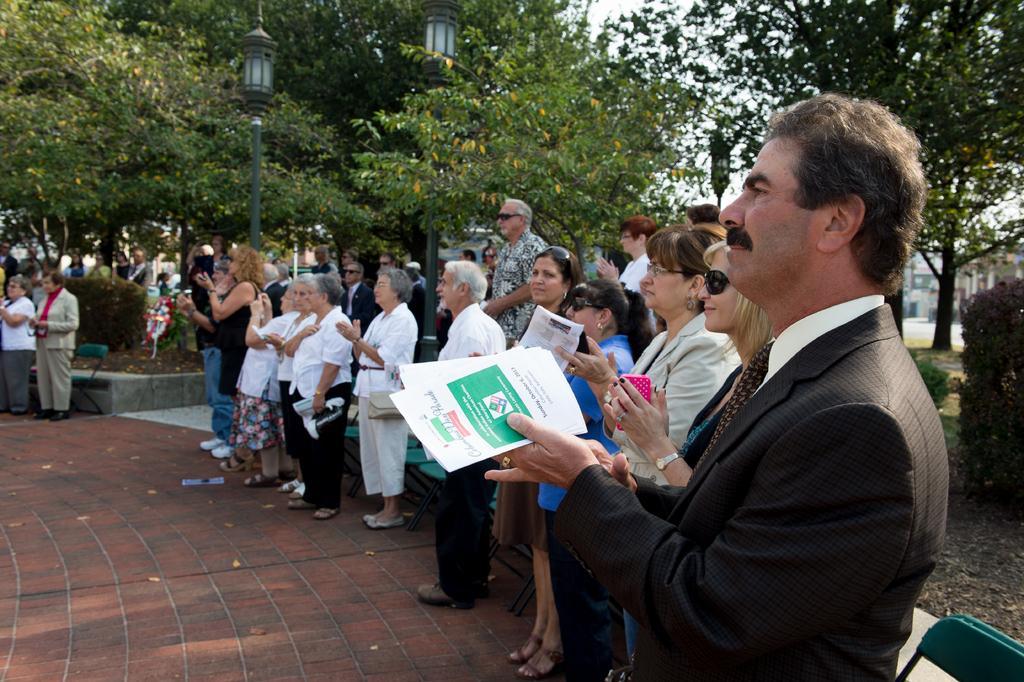Describe this image in one or two sentences. In this image I see a number of people standing on the path and there are chairs behind them which are of green in color. In the background I see a number of trees and few plants and 2 street lights. 